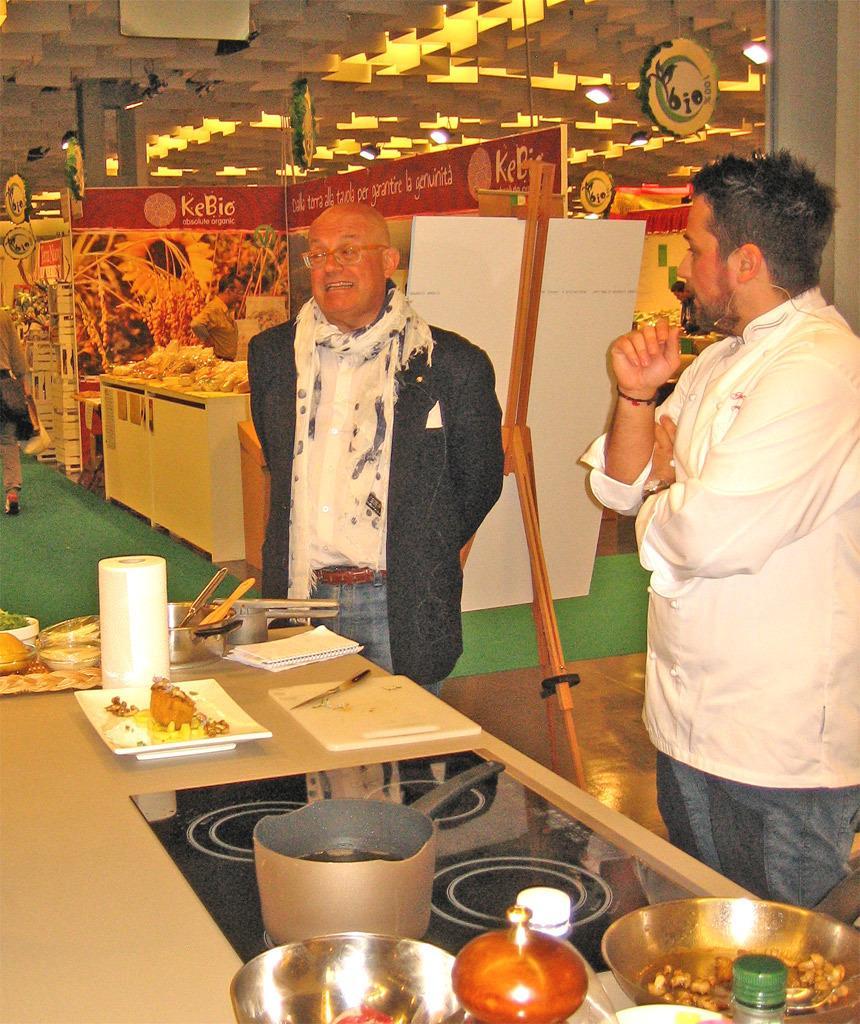In one or two sentences, can you explain what this image depicts? In the image we can see two men standing, wearing clothes and in front if the there is a table. On the table we can see the plate, chopping board, knife, tissue roll, container, bowl and other things. Here we can see poster, floor, board and lights. We can even see a woman walking and wearing clothes. 